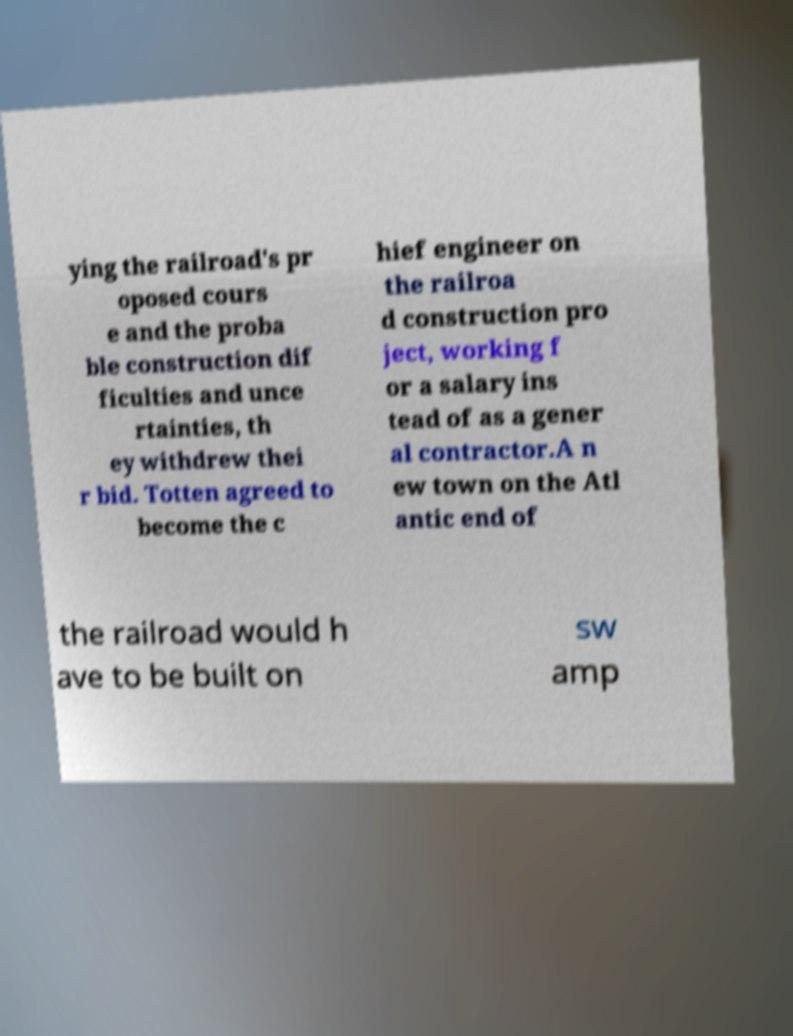Can you accurately transcribe the text from the provided image for me? ying the railroad's pr oposed cours e and the proba ble construction dif ficulties and unce rtainties, th ey withdrew thei r bid. Totten agreed to become the c hief engineer on the railroa d construction pro ject, working f or a salary ins tead of as a gener al contractor.A n ew town on the Atl antic end of the railroad would h ave to be built on sw amp 